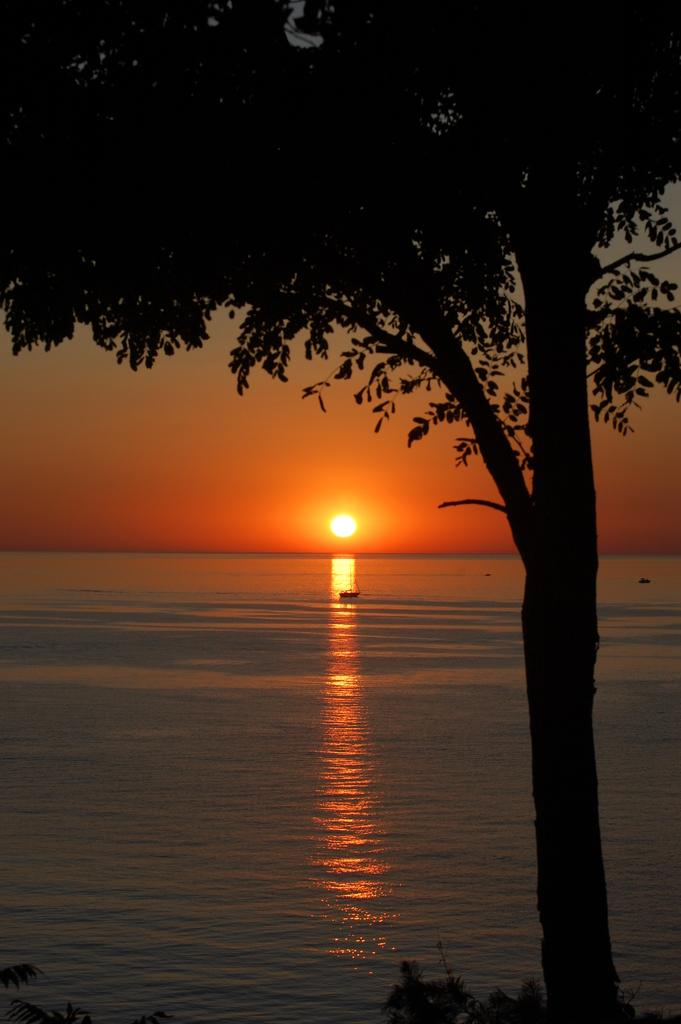What type of vegetation can be seen in the image? There is a tree and plants in the foreground in the image. What is visible in the background of the image? The sky is visible in the image. Can the sun be seen in the sky? Yes, the sun is visible in the sky. What else is present in the image? There is a boat on the water in the image. How many ants are crawling on the tree in the image? There are no ants present on the tree in the image. What type of drink is being served in the boat? There is no drink mentioned or visible in the image; it features a tree, plants, the sky, the sun, and a boat on the water. 